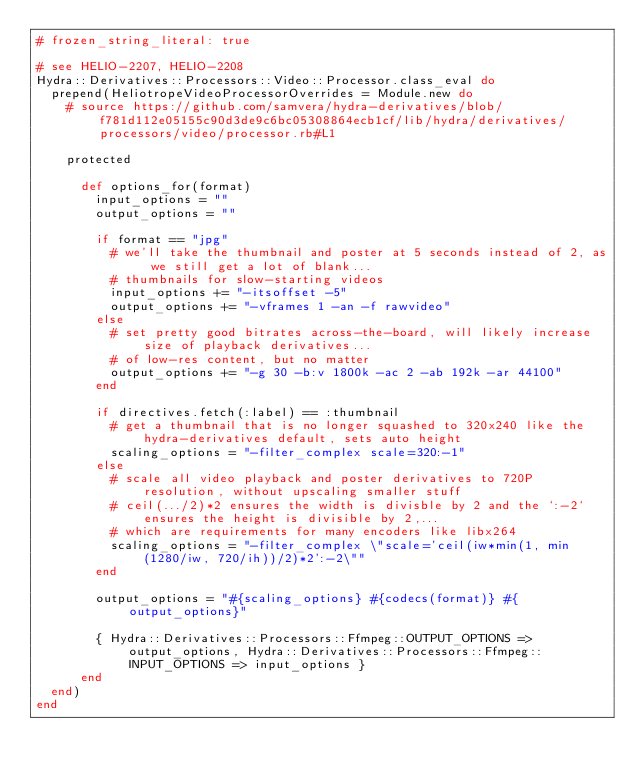<code> <loc_0><loc_0><loc_500><loc_500><_Ruby_># frozen_string_literal: true

# see HELIO-2207, HELIO-2208
Hydra::Derivatives::Processors::Video::Processor.class_eval do
  prepend(HeliotropeVideoProcessorOverrides = Module.new do
    # source https://github.com/samvera/hydra-derivatives/blob/f781d112e05155c90d3de9c6bc05308864ecb1cf/lib/hydra/derivatives/processors/video/processor.rb#L1

    protected

      def options_for(format)
        input_options = ""
        output_options = ""

        if format == "jpg"
          # we'll take the thumbnail and poster at 5 seconds instead of 2, as we still get a lot of blank...
          # thumbnails for slow-starting videos
          input_options += "-itsoffset -5"
          output_options += "-vframes 1 -an -f rawvideo"
        else
          # set pretty good bitrates across-the-board, will likely increase size of playback derivatives...
          # of low-res content, but no matter
          output_options += "-g 30 -b:v 1800k -ac 2 -ab 192k -ar 44100"
        end

        if directives.fetch(:label) == :thumbnail
          # get a thumbnail that is no longer squashed to 320x240 like the hydra-derivatives default, sets auto height
          scaling_options = "-filter_complex scale=320:-1"
        else
          # scale all video playback and poster derivatives to 720P resolution, without upscaling smaller stuff
          # ceil(.../2)*2 ensures the width is divisble by 2 and the `:-2` ensures the height is divisible by 2,...
          # which are requirements for many encoders like libx264
          scaling_options = "-filter_complex \"scale='ceil(iw*min(1, min(1280/iw, 720/ih))/2)*2':-2\""
        end

        output_options = "#{scaling_options} #{codecs(format)} #{output_options}"

        { Hydra::Derivatives::Processors::Ffmpeg::OUTPUT_OPTIONS => output_options, Hydra::Derivatives::Processors::Ffmpeg::INPUT_OPTIONS => input_options }
      end
  end)
end
</code> 